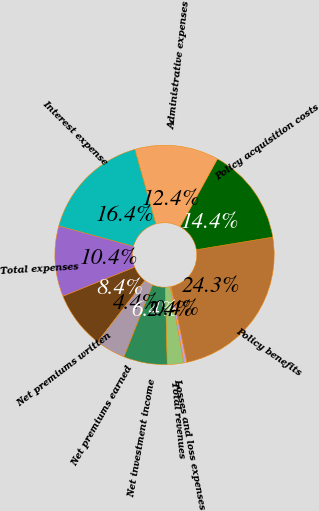Convert chart. <chart><loc_0><loc_0><loc_500><loc_500><pie_chart><fcel>Net premiums written<fcel>Net premiums earned<fcel>Net investment income<fcel>Total revenues<fcel>Losses and loss expenses<fcel>Policy benefits<fcel>Policy acquisition costs<fcel>Administrative expenses<fcel>Interest expense<fcel>Total expenses<nl><fcel>8.41%<fcel>4.42%<fcel>6.42%<fcel>2.43%<fcel>0.44%<fcel>24.34%<fcel>14.38%<fcel>12.39%<fcel>16.37%<fcel>10.4%<nl></chart> 